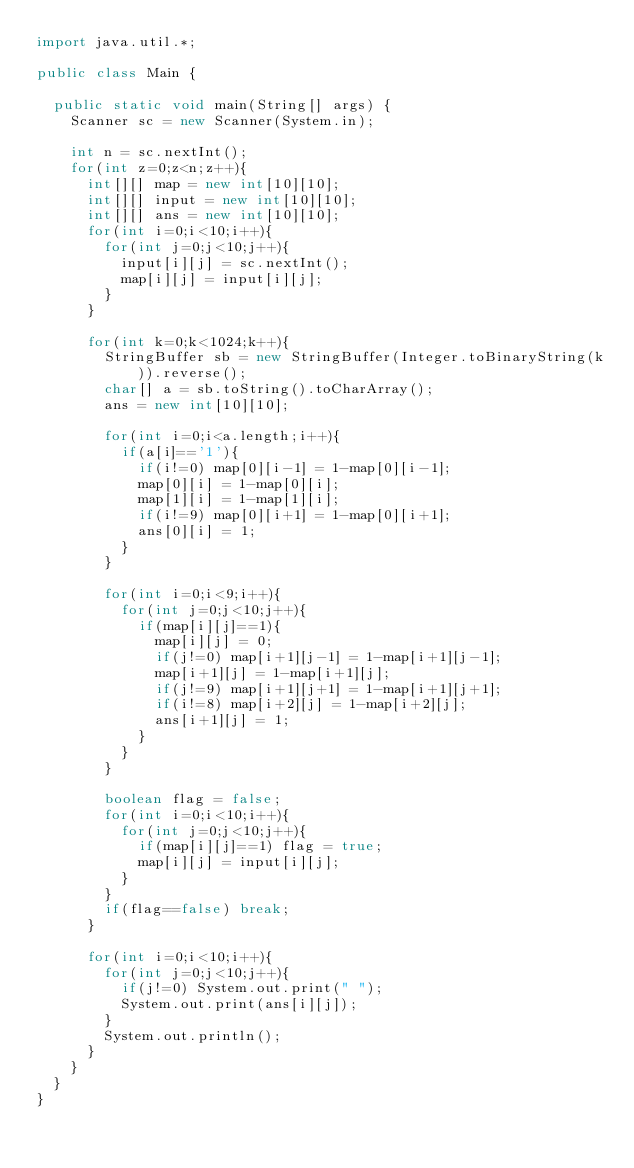Convert code to text. <code><loc_0><loc_0><loc_500><loc_500><_Java_>import java.util.*;

public class Main {
	
	public static void main(String[] args) {
		Scanner sc = new Scanner(System.in);
		
		int n = sc.nextInt();
		for(int z=0;z<n;z++){
			int[][] map = new int[10][10];
			int[][] input = new int[10][10];
			int[][] ans = new int[10][10];
			for(int i=0;i<10;i++){
				for(int j=0;j<10;j++){
					input[i][j] = sc.nextInt();
					map[i][j] = input[i][j];
				}
			}
			
			for(int k=0;k<1024;k++){
				StringBuffer sb = new StringBuffer(Integer.toBinaryString(k)).reverse();
				char[] a = sb.toString().toCharArray();
				ans = new int[10][10];

				for(int i=0;i<a.length;i++){
					if(a[i]=='1'){
						if(i!=0) map[0][i-1] = 1-map[0][i-1];
						map[0][i] = 1-map[0][i];
						map[1][i] = 1-map[1][i];
						if(i!=9) map[0][i+1] = 1-map[0][i+1];
						ans[0][i] = 1;
					}
				}
				
				for(int i=0;i<9;i++){
					for(int j=0;j<10;j++){
						if(map[i][j]==1){
							map[i][j] = 0;
							if(j!=0) map[i+1][j-1] = 1-map[i+1][j-1];
							map[i+1][j] = 1-map[i+1][j];
							if(j!=9) map[i+1][j+1] = 1-map[i+1][j+1];
							if(i!=8) map[i+2][j] = 1-map[i+2][j];
							ans[i+1][j] = 1;
						}
					}
				}
				
				boolean flag = false;
				for(int i=0;i<10;i++){
					for(int j=0;j<10;j++){
						if(map[i][j]==1) flag = true;
						map[i][j] = input[i][j];
					}
				}
				if(flag==false)	break;
			}
			
			for(int i=0;i<10;i++){
				for(int j=0;j<10;j++){
					if(j!=0) System.out.print(" ");
					System.out.print(ans[i][j]);
				}
				System.out.println();
			}
		}
	}	
}</code> 